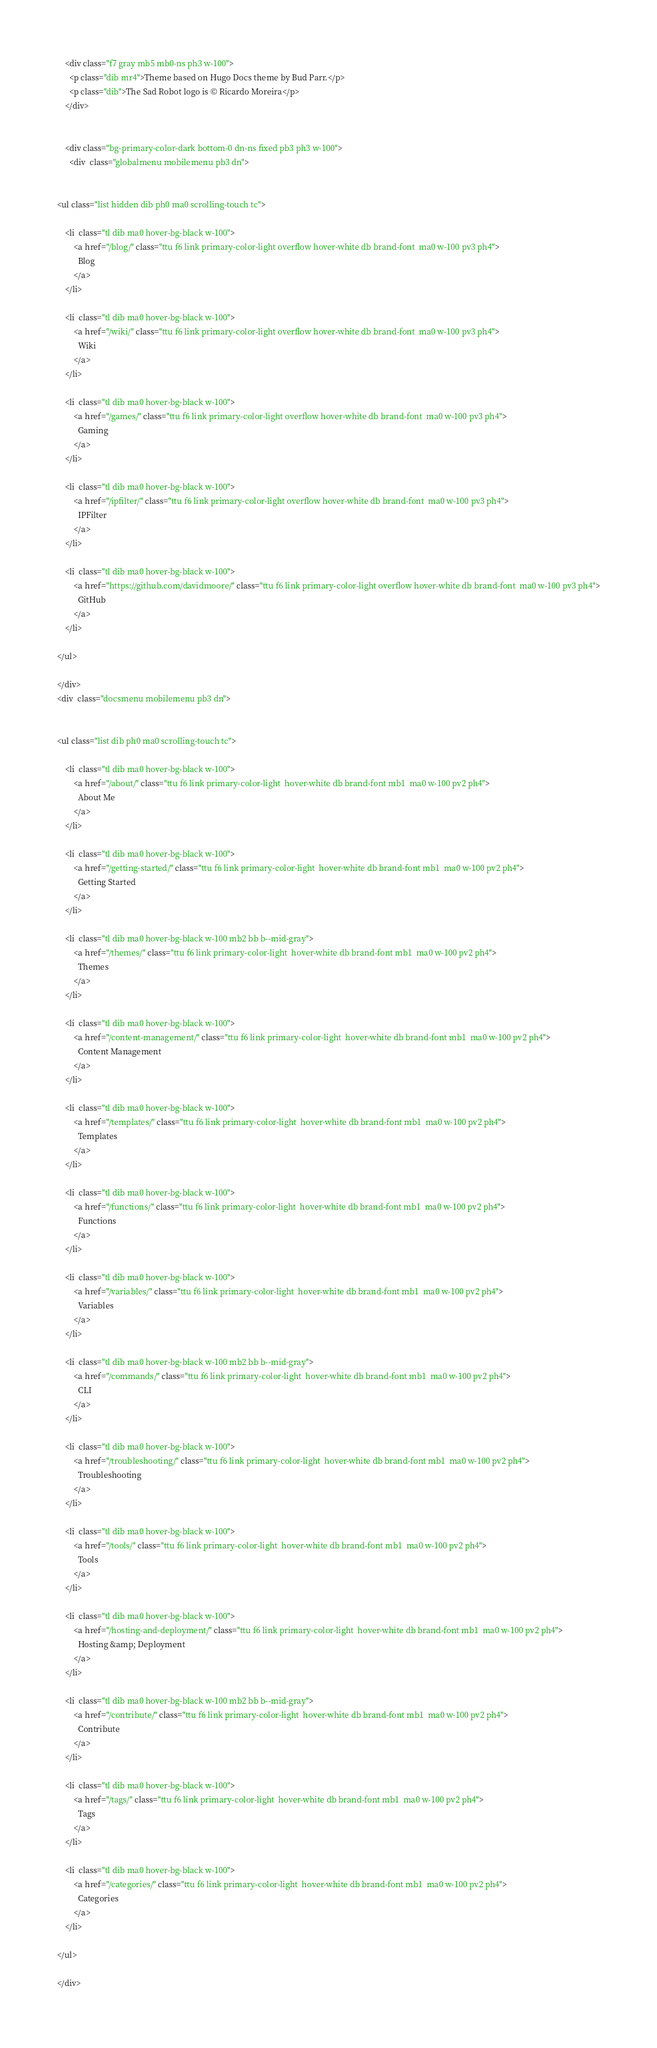<code> <loc_0><loc_0><loc_500><loc_500><_HTML_>
    <div class="f7 gray mb5 mb0-ns ph3 w-100"> 
      <p class="dib mr4">Theme based on Hugo Docs theme by Bud Parr.</p>
      <p class="dib">The Sad Robot logo is © Ricardo Moreira</p>
    </div>
    

    <div class="bg-primary-color-dark bottom-0 dn-ns fixed pb3 ph3 w-100"> 
      <div  class="globalmenu mobilemenu pb3 dn">
    

<ul class="list hidden dib ph0 ma0 scrolling-touch tc">
  
    <li  class="tl dib ma0 hover-bg-black w-100">
        <a href="/blog/" class="ttu f6 link primary-color-light overflow hover-white db brand-font  ma0 w-100 pv3 ph4">
          Blog
        </a>
    </li>
  
    <li  class="tl dib ma0 hover-bg-black w-100">
        <a href="/wiki/" class="ttu f6 link primary-color-light overflow hover-white db brand-font  ma0 w-100 pv3 ph4">
          Wiki
        </a>
    </li>
  
    <li  class="tl dib ma0 hover-bg-black w-100">
        <a href="/games/" class="ttu f6 link primary-color-light overflow hover-white db brand-font  ma0 w-100 pv3 ph4">
          Gaming
        </a>
    </li>
  
    <li  class="tl dib ma0 hover-bg-black w-100">
        <a href="/ipfilter/" class="ttu f6 link primary-color-light overflow hover-white db brand-font  ma0 w-100 pv3 ph4">
          IPFilter
        </a>
    </li>
  
    <li  class="tl dib ma0 hover-bg-black w-100">
        <a href="https://github.com/davidmoore/" class="ttu f6 link primary-color-light overflow hover-white db brand-font  ma0 w-100 pv3 ph4">
          GitHub
        </a>
    </li>
  
</ul>

</div>
<div  class="docsmenu mobilemenu pb3 dn">
    

<ul class="list dib ph0 ma0 scrolling-touch tc">
  
    <li  class="tl dib ma0 hover-bg-black w-100">
        <a href="/about/" class="ttu f6 link primary-color-light  hover-white db brand-font mb1  ma0 w-100 pv2 ph4">
          About Me
        </a>
    </li>
  
    <li  class="tl dib ma0 hover-bg-black w-100">
        <a href="/getting-started/" class="ttu f6 link primary-color-light  hover-white db brand-font mb1  ma0 w-100 pv2 ph4">
          Getting Started
        </a>
    </li>
  
    <li  class="tl dib ma0 hover-bg-black w-100 mb2 bb b--mid-gray">
        <a href="/themes/" class="ttu f6 link primary-color-light  hover-white db brand-font mb1  ma0 w-100 pv2 ph4">
          Themes
        </a>
    </li>
  
    <li  class="tl dib ma0 hover-bg-black w-100">
        <a href="/content-management/" class="ttu f6 link primary-color-light  hover-white db brand-font mb1  ma0 w-100 pv2 ph4">
          Content Management
        </a>
    </li>
  
    <li  class="tl dib ma0 hover-bg-black w-100">
        <a href="/templates/" class="ttu f6 link primary-color-light  hover-white db brand-font mb1  ma0 w-100 pv2 ph4">
          Templates
        </a>
    </li>
  
    <li  class="tl dib ma0 hover-bg-black w-100">
        <a href="/functions/" class="ttu f6 link primary-color-light  hover-white db brand-font mb1  ma0 w-100 pv2 ph4">
          Functions
        </a>
    </li>
  
    <li  class="tl dib ma0 hover-bg-black w-100">
        <a href="/variables/" class="ttu f6 link primary-color-light  hover-white db brand-font mb1  ma0 w-100 pv2 ph4">
          Variables
        </a>
    </li>
  
    <li  class="tl dib ma0 hover-bg-black w-100 mb2 bb b--mid-gray">
        <a href="/commands/" class="ttu f6 link primary-color-light  hover-white db brand-font mb1  ma0 w-100 pv2 ph4">
          CLI
        </a>
    </li>
  
    <li  class="tl dib ma0 hover-bg-black w-100">
        <a href="/troubleshooting/" class="ttu f6 link primary-color-light  hover-white db brand-font mb1  ma0 w-100 pv2 ph4">
          Troubleshooting
        </a>
    </li>
  
    <li  class="tl dib ma0 hover-bg-black w-100">
        <a href="/tools/" class="ttu f6 link primary-color-light  hover-white db brand-font mb1  ma0 w-100 pv2 ph4">
          Tools
        </a>
    </li>
  
    <li  class="tl dib ma0 hover-bg-black w-100">
        <a href="/hosting-and-deployment/" class="ttu f6 link primary-color-light  hover-white db brand-font mb1  ma0 w-100 pv2 ph4">
          Hosting &amp; Deployment
        </a>
    </li>
  
    <li  class="tl dib ma0 hover-bg-black w-100 mb2 bb b--mid-gray">
        <a href="/contribute/" class="ttu f6 link primary-color-light  hover-white db brand-font mb1  ma0 w-100 pv2 ph4">
          Contribute
        </a>
    </li>
  
    <li  class="tl dib ma0 hover-bg-black w-100">
        <a href="/tags/" class="ttu f6 link primary-color-light  hover-white db brand-font mb1  ma0 w-100 pv2 ph4">
          Tags
        </a>
    </li>
  
    <li  class="tl dib ma0 hover-bg-black w-100">
        <a href="/categories/" class="ttu f6 link primary-color-light  hover-white db brand-font mb1  ma0 w-100 pv2 ph4">
          Categories
        </a>
    </li>
  
</ul>

</div>
</code> 